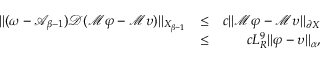Convert formula to latex. <formula><loc_0><loc_0><loc_500><loc_500>\begin{array} { r l r } { \| ( \omega - \mathcal { A } _ { \beta - 1 } ) \mathcal { D } ( \mathcal { M } \varphi - \mathcal { M } \upsilon ) \| _ { X _ { \beta - 1 } } } & { \leq } & { c \| \mathcal { M } \varphi - \mathcal { M } \upsilon \| _ { \partial X } } \\ & { \leq } & { c L _ { R } ^ { 9 } \| \varphi - \upsilon \| _ { \alpha } , } \end{array}</formula> 